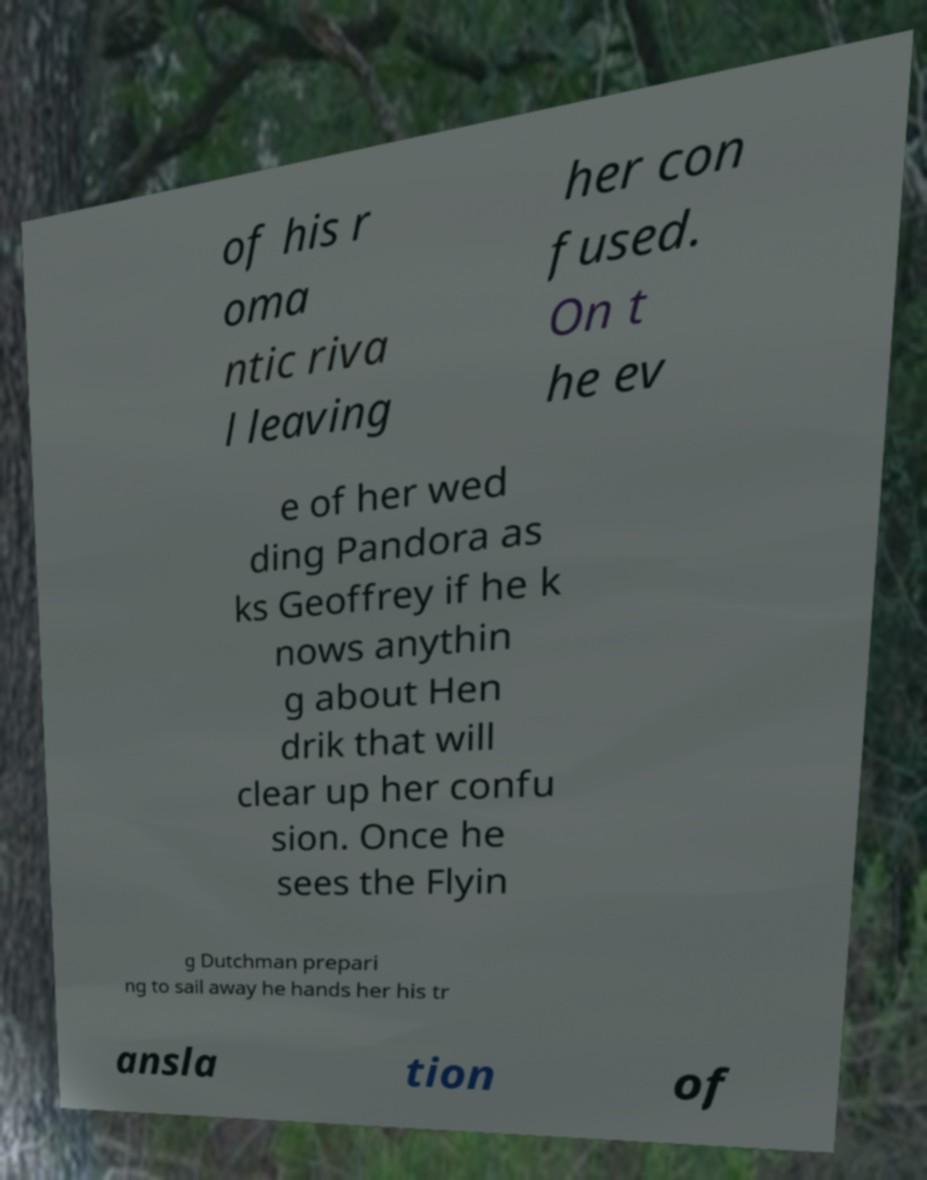Could you assist in decoding the text presented in this image and type it out clearly? of his r oma ntic riva l leaving her con fused. On t he ev e of her wed ding Pandora as ks Geoffrey if he k nows anythin g about Hen drik that will clear up her confu sion. Once he sees the Flyin g Dutchman prepari ng to sail away he hands her his tr ansla tion of 